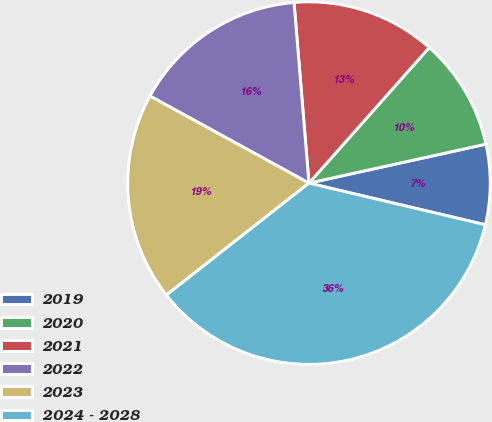<chart> <loc_0><loc_0><loc_500><loc_500><pie_chart><fcel>2019<fcel>2020<fcel>2021<fcel>2022<fcel>2023<fcel>2024 - 2028<nl><fcel>7.14%<fcel>10.0%<fcel>12.86%<fcel>15.71%<fcel>18.57%<fcel>35.71%<nl></chart> 